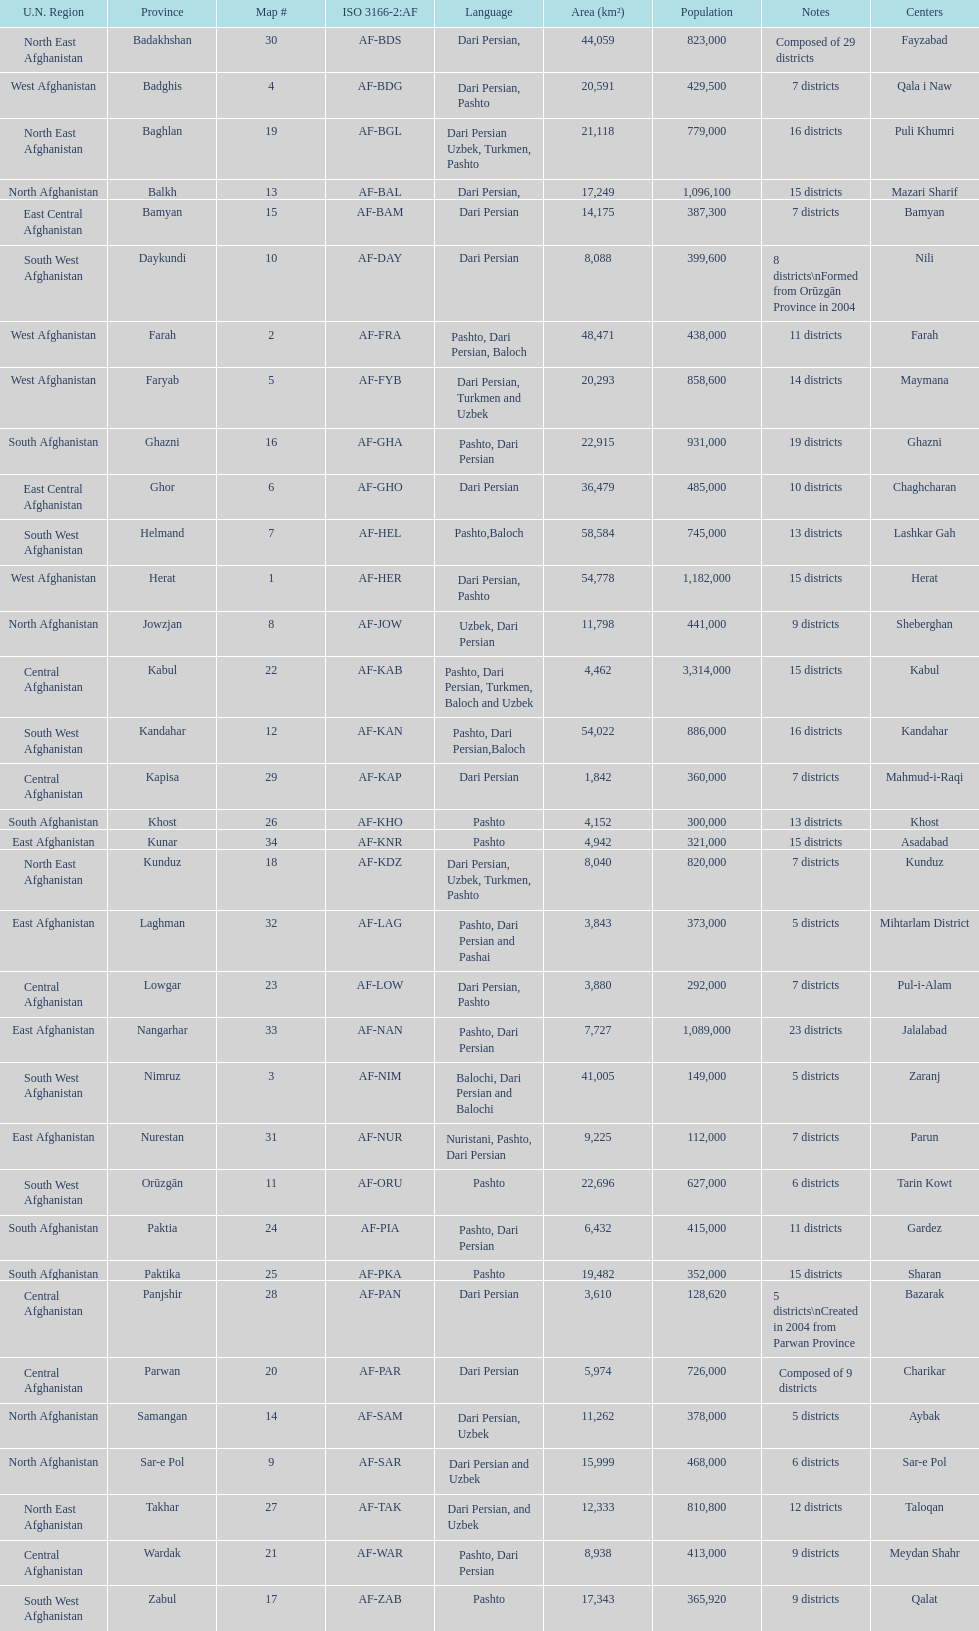Give the province with the least population Nurestan. 